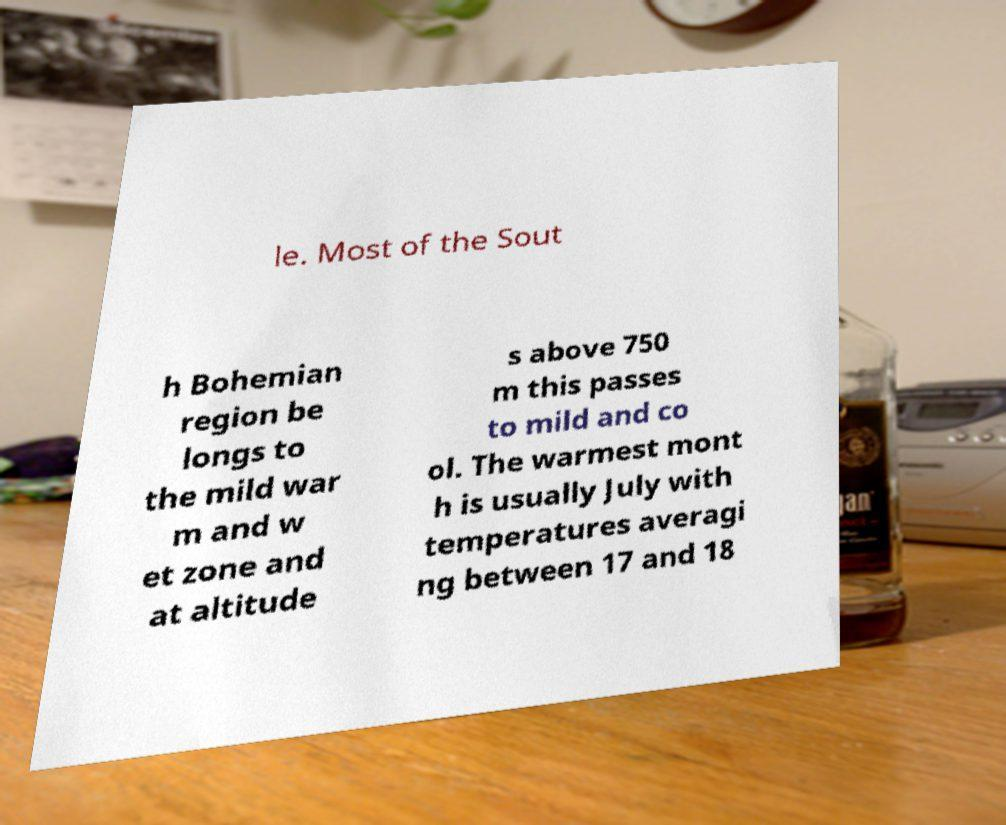I need the written content from this picture converted into text. Can you do that? le. Most of the Sout h Bohemian region be longs to the mild war m and w et zone and at altitude s above 750 m this passes to mild and co ol. The warmest mont h is usually July with temperatures averagi ng between 17 and 18 